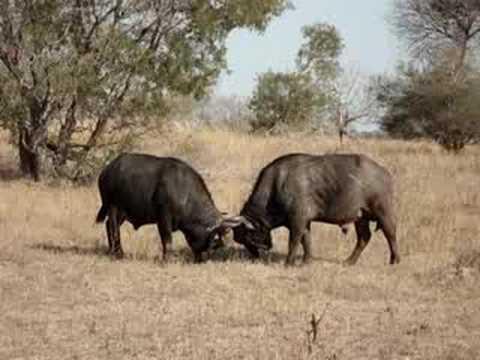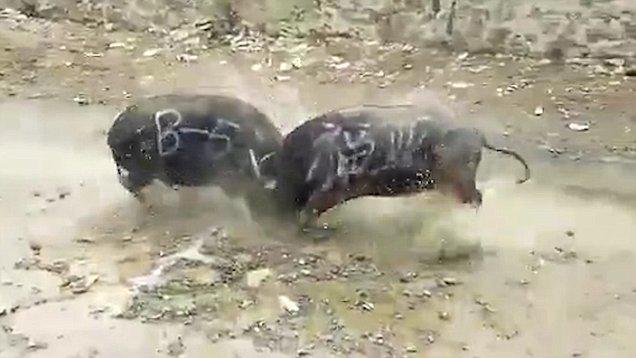The first image is the image on the left, the second image is the image on the right. Given the left and right images, does the statement "There are four animals in total in the image pair." hold true? Answer yes or no. Yes. 